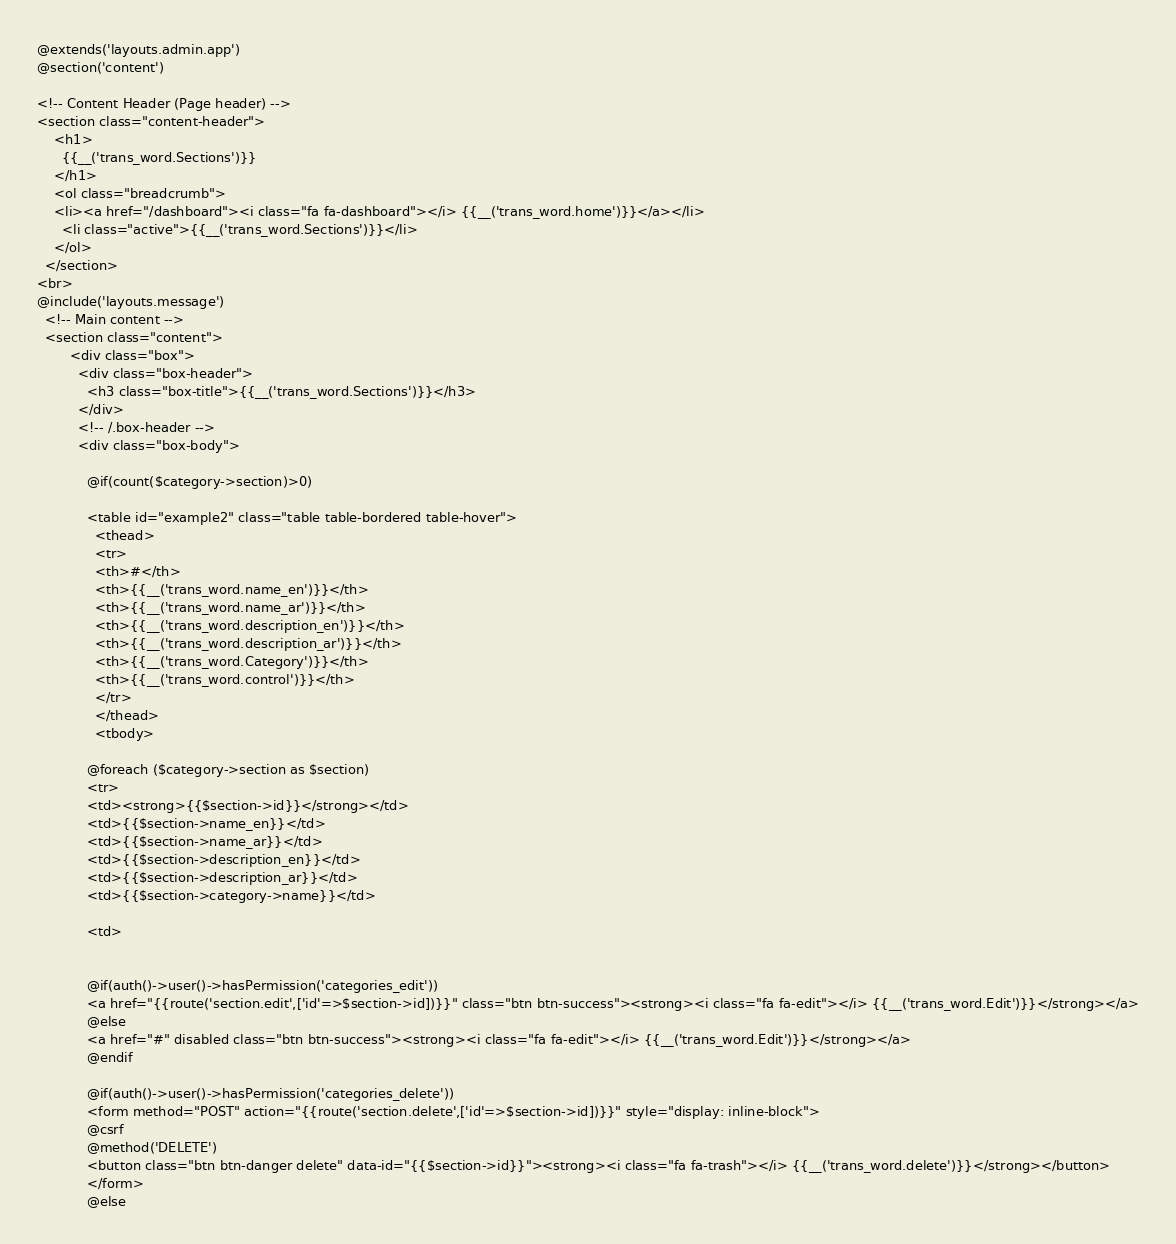Convert code to text. <code><loc_0><loc_0><loc_500><loc_500><_PHP_>@extends('layouts.admin.app')
@section('content')

<!-- Content Header (Page header) -->
<section class="content-header">
    <h1>
      {{__('trans_word.Sections')}}
    </h1>
    <ol class="breadcrumb">
    <li><a href="/dashboard"><i class="fa fa-dashboard"></i> {{__('trans_word.home')}}</a></li>
      <li class="active">{{__('trans_word.Sections')}}</li>
    </ol>
  </section>
<br>
@include('layouts.message')
  <!-- Main content -->
  <section class="content">
        <div class="box">
          <div class="box-header">
            <h3 class="box-title">{{__('trans_word.Sections')}}</h3>
          </div>
          <!-- /.box-header -->
          <div class="box-body">

            @if(count($category->section)>0)

            <table id="example2" class="table table-bordered table-hover">
              <thead>
              <tr>
              <th>#</th>
              <th>{{__('trans_word.name_en')}}</th>
              <th>{{__('trans_word.name_ar')}}</th>
              <th>{{__('trans_word.description_en')}}</th>
              <th>{{__('trans_word.description_ar')}}</th>
              <th>{{__('trans_word.Category')}}</th>
              <th>{{__('trans_word.control')}}</th>
              </tr>
              </thead>
              <tbody>
    
            @foreach ($category->section as $section)
            <tr>
            <td><strong>{{$section->id}}</strong></td>
            <td>{{$section->name_en}}</td>
            <td>{{$section->name_ar}}</td>
            <td>{{$section->description_en}}</td>
            <td>{{$section->description_ar}}</td>
            <td>{{$section->category->name}}</td>

            <td>


            @if(auth()->user()->hasPermission('categories_edit'))
            <a href="{{route('section.edit',['id'=>$section->id])}}" class="btn btn-success"><strong><i class="fa fa-edit"></i> {{__('trans_word.Edit')}}</strong></a>
            @else
            <a href="#" disabled class="btn btn-success"><strong><i class="fa fa-edit"></i> {{__('trans_word.Edit')}}</strong></a>
            @endif

            @if(auth()->user()->hasPermission('categories_delete'))
            <form method="POST" action="{{route('section.delete',['id'=>$section->id])}}" style="display: inline-block">
            @csrf
            @method('DELETE')
            <button class="btn btn-danger delete" data-id="{{$section->id}}"><strong><i class="fa fa-trash"></i> {{__('trans_word.delete')}}</strong></button>
            </form>
            @else</code> 